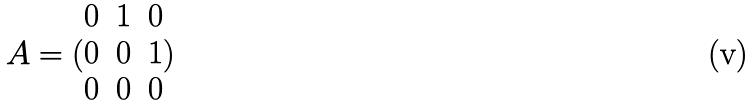Convert formula to latex. <formula><loc_0><loc_0><loc_500><loc_500>A = ( \begin{matrix} 0 & 1 & 0 \\ 0 & 0 & 1 \\ 0 & 0 & 0 \end{matrix} )</formula> 